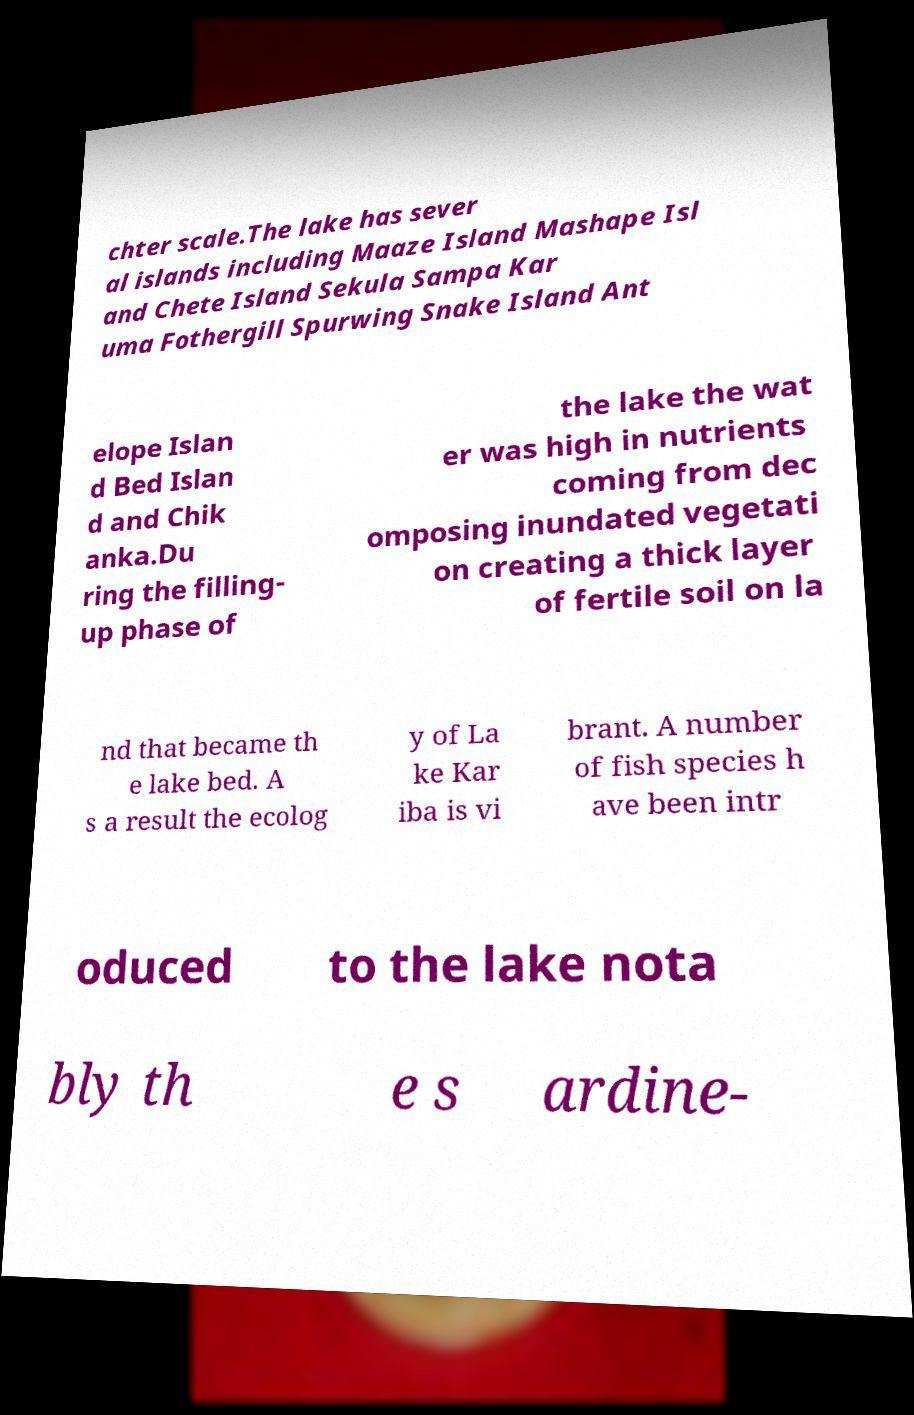Could you extract and type out the text from this image? chter scale.The lake has sever al islands including Maaze Island Mashape Isl and Chete Island Sekula Sampa Kar uma Fothergill Spurwing Snake Island Ant elope Islan d Bed Islan d and Chik anka.Du ring the filling- up phase of the lake the wat er was high in nutrients coming from dec omposing inundated vegetati on creating a thick layer of fertile soil on la nd that became th e lake bed. A s a result the ecolog y of La ke Kar iba is vi brant. A number of fish species h ave been intr oduced to the lake nota bly th e s ardine- 